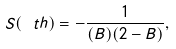<formula> <loc_0><loc_0><loc_500><loc_500>S ( \ t h ) = - \frac { 1 } { ( B ) ( 2 - B ) } ,</formula> 